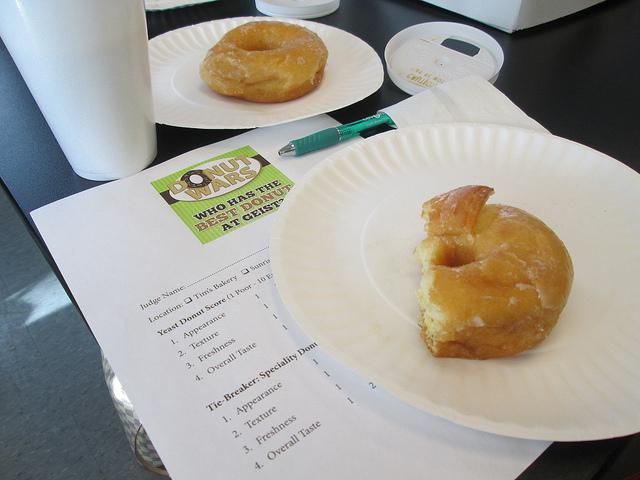Is there a phone?
Give a very brief answer. No. Is that a pencil on the table?
Quick response, please. No. What kind of donut is on the plate?
Write a very short answer. Glazed. Are there any sprinkles?
Give a very brief answer. No. What is written on the paper?
Write a very short answer. Donut wars. What brand of donuts is this?
Short answer required. Donut wars. Is there a picture of a cup of coffee on the menu?
Give a very brief answer. No. What kind of food is this?
Concise answer only. Donut. Where are these donuts from?
Write a very short answer. Donut wars. Where is the doughnut placed?
Answer briefly. Plate. What has happened to the pastry on the left?
Keep it brief. Nothing. What kind of food is pictured?
Write a very short answer. Donut. What kind of magazines are on the table?
Write a very short answer. No magazines. Is the donut filled?
Give a very brief answer. No. Are the plates made of glass?
Quick response, please. No. What is the plate made of?
Write a very short answer. Paper. Is this plate made of paper?
Keep it brief. Yes. How many glazed doughnuts are there?
Write a very short answer. 2. Do you see a donut?
Short answer required. Yes. How many power outlets are there?
Be succinct. 0. What kind of pastry is this?
Short answer required. Donut. How many donuts are on the plate?
Keep it brief. 1. 